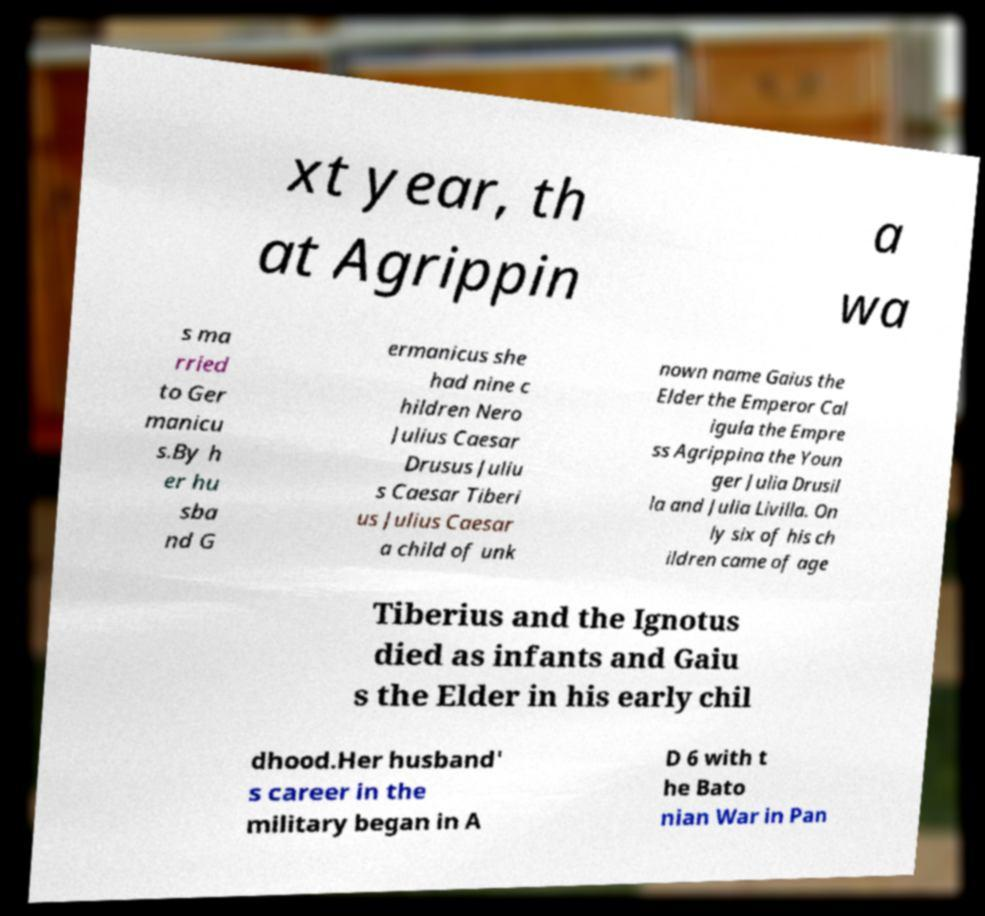Could you assist in decoding the text presented in this image and type it out clearly? xt year, th at Agrippin a wa s ma rried to Ger manicu s.By h er hu sba nd G ermanicus she had nine c hildren Nero Julius Caesar Drusus Juliu s Caesar Tiberi us Julius Caesar a child of unk nown name Gaius the Elder the Emperor Cal igula the Empre ss Agrippina the Youn ger Julia Drusil la and Julia Livilla. On ly six of his ch ildren came of age Tiberius and the Ignotus died as infants and Gaiu s the Elder in his early chil dhood.Her husband' s career in the military began in A D 6 with t he Bato nian War in Pan 